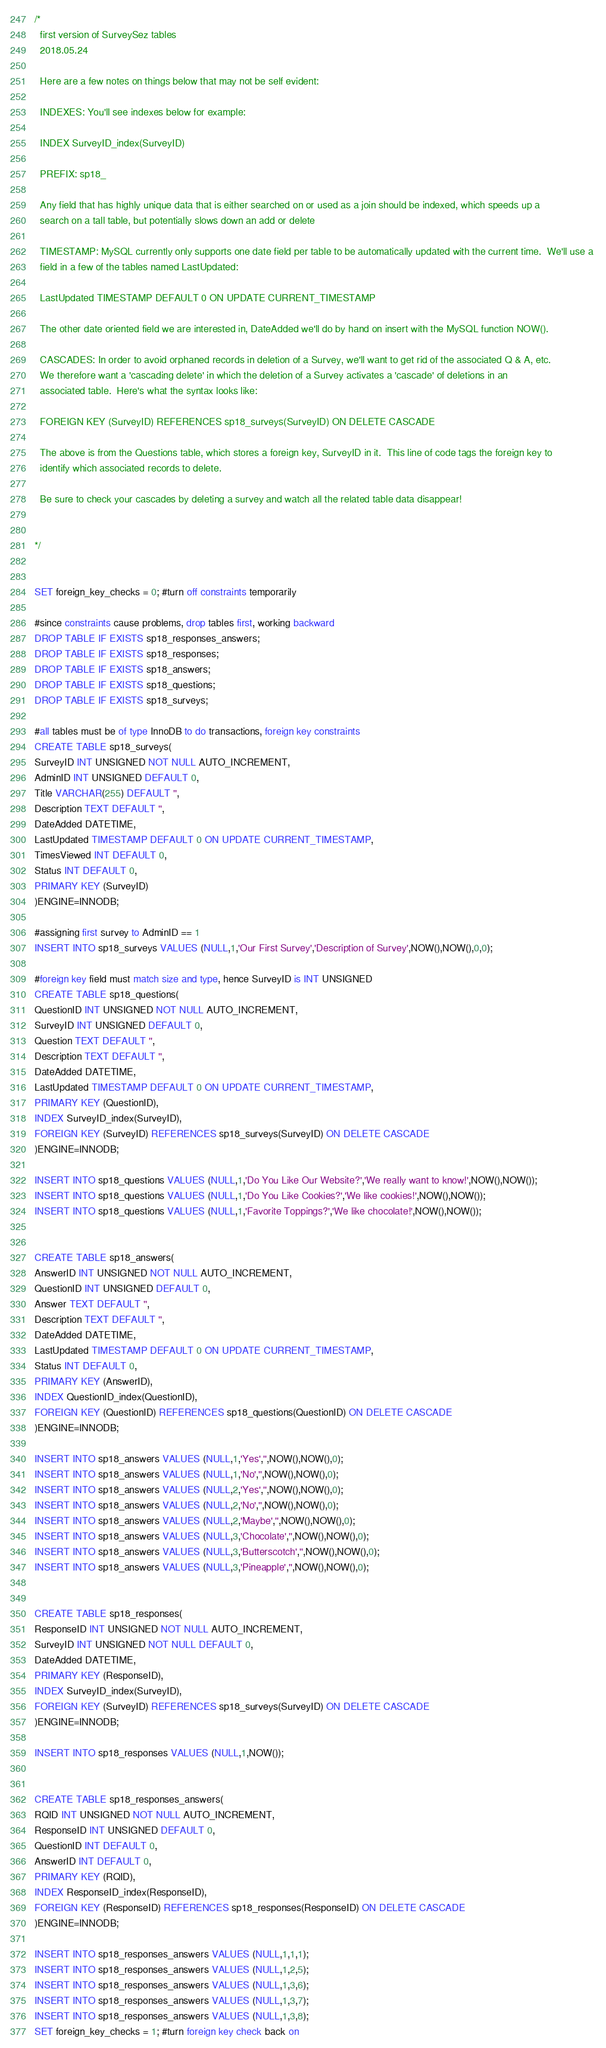Convert code to text. <code><loc_0><loc_0><loc_500><loc_500><_SQL_>/*
  first version of SurveySez tables
  2018.05.24
  
  Here are a few notes on things below that may not be self evident:
  
  INDEXES: You'll see indexes below for example:
  
  INDEX SurveyID_index(SurveyID)

  PREFIX: sp18_
  
  Any field that has highly unique data that is either searched on or used as a join should be indexed, which speeds up a  
  search on a tall table, but potentially slows down an add or delete
  
  TIMESTAMP: MySQL currently only supports one date field per table to be automatically updated with the current time.  We'll use a 
  field in a few of the tables named LastUpdated:
  
  LastUpdated TIMESTAMP DEFAULT 0 ON UPDATE CURRENT_TIMESTAMP
  
  The other date oriented field we are interested in, DateAdded we'll do by hand on insert with the MySQL function NOW().
  
  CASCADES: In order to avoid orphaned records in deletion of a Survey, we'll want to get rid of the associated Q & A, etc. 
  We therefore want a 'cascading delete' in which the deletion of a Survey activates a 'cascade' of deletions in an 
  associated table.  Here's what the syntax looks like:  
  
  FOREIGN KEY (SurveyID) REFERENCES sp18_surveys(SurveyID) ON DELETE CASCADE
  
  The above is from the Questions table, which stores a foreign key, SurveyID in it.  This line of code tags the foreign key to 
  identify which associated records to delete.
  
  Be sure to check your cascades by deleting a survey and watch all the related table data disappear!
  
  
*/


SET foreign_key_checks = 0; #turn off constraints temporarily

#since constraints cause problems, drop tables first, working backward
DROP TABLE IF EXISTS sp18_responses_answers; 
DROP TABLE IF EXISTS sp18_responses;
DROP TABLE IF EXISTS sp18_answers;
DROP TABLE IF EXISTS sp18_questions;
DROP TABLE IF EXISTS sp18_surveys;
  
#all tables must be of type InnoDB to do transactions, foreign key constraints
CREATE TABLE sp18_surveys(
SurveyID INT UNSIGNED NOT NULL AUTO_INCREMENT,
AdminID INT UNSIGNED DEFAULT 0,
Title VARCHAR(255) DEFAULT '',
Description TEXT DEFAULT '',
DateAdded DATETIME,
LastUpdated TIMESTAMP DEFAULT 0 ON UPDATE CURRENT_TIMESTAMP,
TimesViewed INT DEFAULT 0,
Status INT DEFAULT 0,
PRIMARY KEY (SurveyID)
)ENGINE=INNODB; 

#assigning first survey to AdminID == 1
INSERT INTO sp18_surveys VALUES (NULL,1,'Our First Survey','Description of Survey',NOW(),NOW(),0,0); 

#foreign key field must match size and type, hence SurveyID is INT UNSIGNED
CREATE TABLE sp18_questions(
QuestionID INT UNSIGNED NOT NULL AUTO_INCREMENT,
SurveyID INT UNSIGNED DEFAULT 0,
Question TEXT DEFAULT '',
Description TEXT DEFAULT '',
DateAdded DATETIME,
LastUpdated TIMESTAMP DEFAULT 0 ON UPDATE CURRENT_TIMESTAMP,
PRIMARY KEY (QuestionID),
INDEX SurveyID_index(SurveyID),
FOREIGN KEY (SurveyID) REFERENCES sp18_surveys(SurveyID) ON DELETE CASCADE
)ENGINE=INNODB;

INSERT INTO sp18_questions VALUES (NULL,1,'Do You Like Our Website?','We really want to know!',NOW(),NOW());
INSERT INTO sp18_questions VALUES (NULL,1,'Do You Like Cookies?','We like cookies!',NOW(),NOW());
INSERT INTO sp18_questions VALUES (NULL,1,'Favorite Toppings?','We like chocolate!',NOW(),NOW());


CREATE TABLE sp18_answers(
AnswerID INT UNSIGNED NOT NULL AUTO_INCREMENT,
QuestionID INT UNSIGNED DEFAULT 0,
Answer TEXT DEFAULT '',
Description TEXT DEFAULT '',
DateAdded DATETIME,
LastUpdated TIMESTAMP DEFAULT 0 ON UPDATE CURRENT_TIMESTAMP,
Status INT DEFAULT 0,
PRIMARY KEY (AnswerID),
INDEX QuestionID_index(QuestionID),
FOREIGN KEY (QuestionID) REFERENCES sp18_questions(QuestionID) ON DELETE CASCADE
)ENGINE=INNODB;

INSERT INTO sp18_answers VALUES (NULL,1,'Yes','',NOW(),NOW(),0);
INSERT INTO sp18_answers VALUES (NULL,1,'No','',NOW(),NOW(),0);
INSERT INTO sp18_answers VALUES (NULL,2,'Yes','',NOW(),NOW(),0);
INSERT INTO sp18_answers VALUES (NULL,2,'No','',NOW(),NOW(),0);
INSERT INTO sp18_answers VALUES (NULL,2,'Maybe','',NOW(),NOW(),0);
INSERT INTO sp18_answers VALUES (NULL,3,'Chocolate','',NOW(),NOW(),0);
INSERT INTO sp18_answers VALUES (NULL,3,'Butterscotch','',NOW(),NOW(),0);
INSERT INTO sp18_answers VALUES (NULL,3,'Pineapple','',NOW(),NOW(),0);


CREATE TABLE sp18_responses(
ResponseID INT UNSIGNED NOT NULL AUTO_INCREMENT,
SurveyID INT UNSIGNED NOT NULL DEFAULT 0,
DateAdded DATETIME,
PRIMARY KEY (ResponseID),
INDEX SurveyID_index(SurveyID),
FOREIGN KEY (SurveyID) REFERENCES sp18_surveys(SurveyID) ON DELETE CASCADE
)ENGINE=INNODB;

INSERT INTO sp18_responses VALUES (NULL,1,NOW());


CREATE TABLE sp18_responses_answers(
RQID INT UNSIGNED NOT NULL AUTO_INCREMENT,
ResponseID INT UNSIGNED DEFAULT 0,
QuestionID INT DEFAULT 0,
AnswerID INT DEFAULT 0,
PRIMARY KEY (RQID),
INDEX ResponseID_index(ResponseID),
FOREIGN KEY (ResponseID) REFERENCES sp18_responses(ResponseID) ON DELETE CASCADE
)ENGINE=INNODB;

INSERT INTO sp18_responses_answers VALUES (NULL,1,1,1);
INSERT INTO sp18_responses_answers VALUES (NULL,1,2,5);
INSERT INTO sp18_responses_answers VALUES (NULL,1,3,6);
INSERT INTO sp18_responses_answers VALUES (NULL,1,3,7);
INSERT INTO sp18_responses_answers VALUES (NULL,1,3,8);
SET foreign_key_checks = 1; #turn foreign key check back on
</code> 